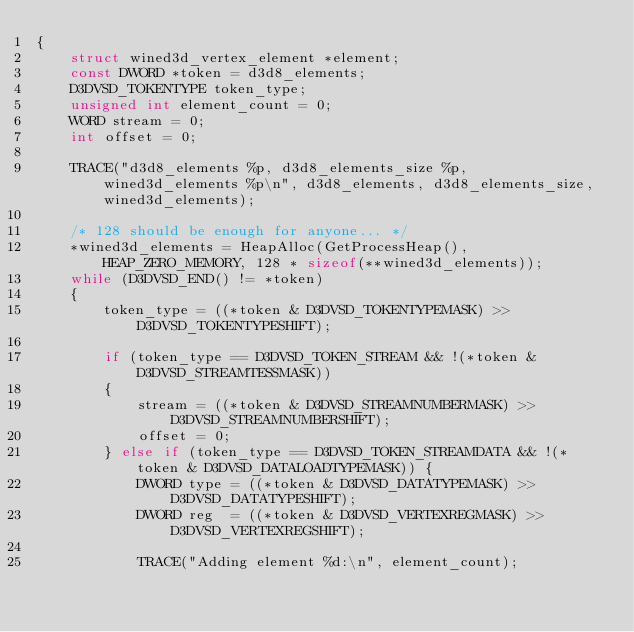<code> <loc_0><loc_0><loc_500><loc_500><_C_>{
    struct wined3d_vertex_element *element;
    const DWORD *token = d3d8_elements;
    D3DVSD_TOKENTYPE token_type;
    unsigned int element_count = 0;
    WORD stream = 0;
    int offset = 0;

    TRACE("d3d8_elements %p, d3d8_elements_size %p, wined3d_elements %p\n", d3d8_elements, d3d8_elements_size, wined3d_elements);

    /* 128 should be enough for anyone... */
    *wined3d_elements = HeapAlloc(GetProcessHeap(), HEAP_ZERO_MEMORY, 128 * sizeof(**wined3d_elements));
    while (D3DVSD_END() != *token)
    {
        token_type = ((*token & D3DVSD_TOKENTYPEMASK) >> D3DVSD_TOKENTYPESHIFT);

        if (token_type == D3DVSD_TOKEN_STREAM && !(*token & D3DVSD_STREAMTESSMASK))
        {
            stream = ((*token & D3DVSD_STREAMNUMBERMASK) >> D3DVSD_STREAMNUMBERSHIFT);
            offset = 0;
        } else if (token_type == D3DVSD_TOKEN_STREAMDATA && !(*token & D3DVSD_DATALOADTYPEMASK)) {
            DWORD type = ((*token & D3DVSD_DATATYPEMASK) >> D3DVSD_DATATYPESHIFT);
            DWORD reg  = ((*token & D3DVSD_VERTEXREGMASK) >> D3DVSD_VERTEXREGSHIFT);

            TRACE("Adding element %d:\n", element_count);
</code> 